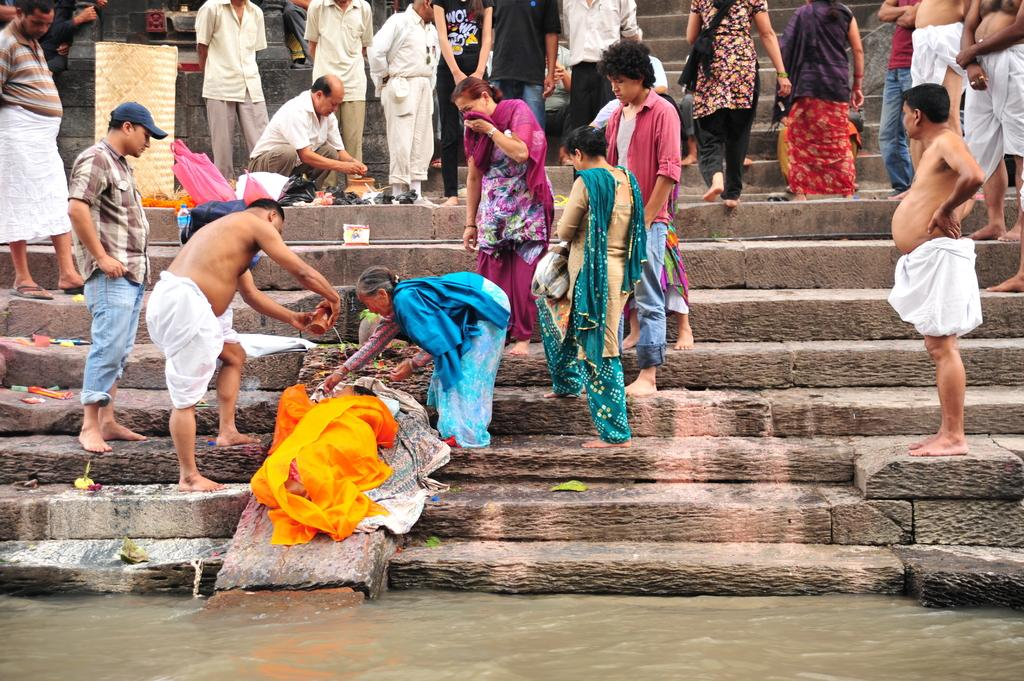How many people are in the image? There are people in the image, but the exact number is not specified. What are some of the people holding in the image? Some people are holding objects in the image, but the specific objects are not mentioned. What architectural feature can be seen in the image? There are stairs in the image. What natural element is visible in the image? There is water visible in the image. What type of items can be seen in the image? There are cloth items and bags in the image. What is the only container visible in the image? There is a bottle in the image. Can you see any twigs in the image? There is no mention of twigs in the image, so we cannot confirm their presence. 